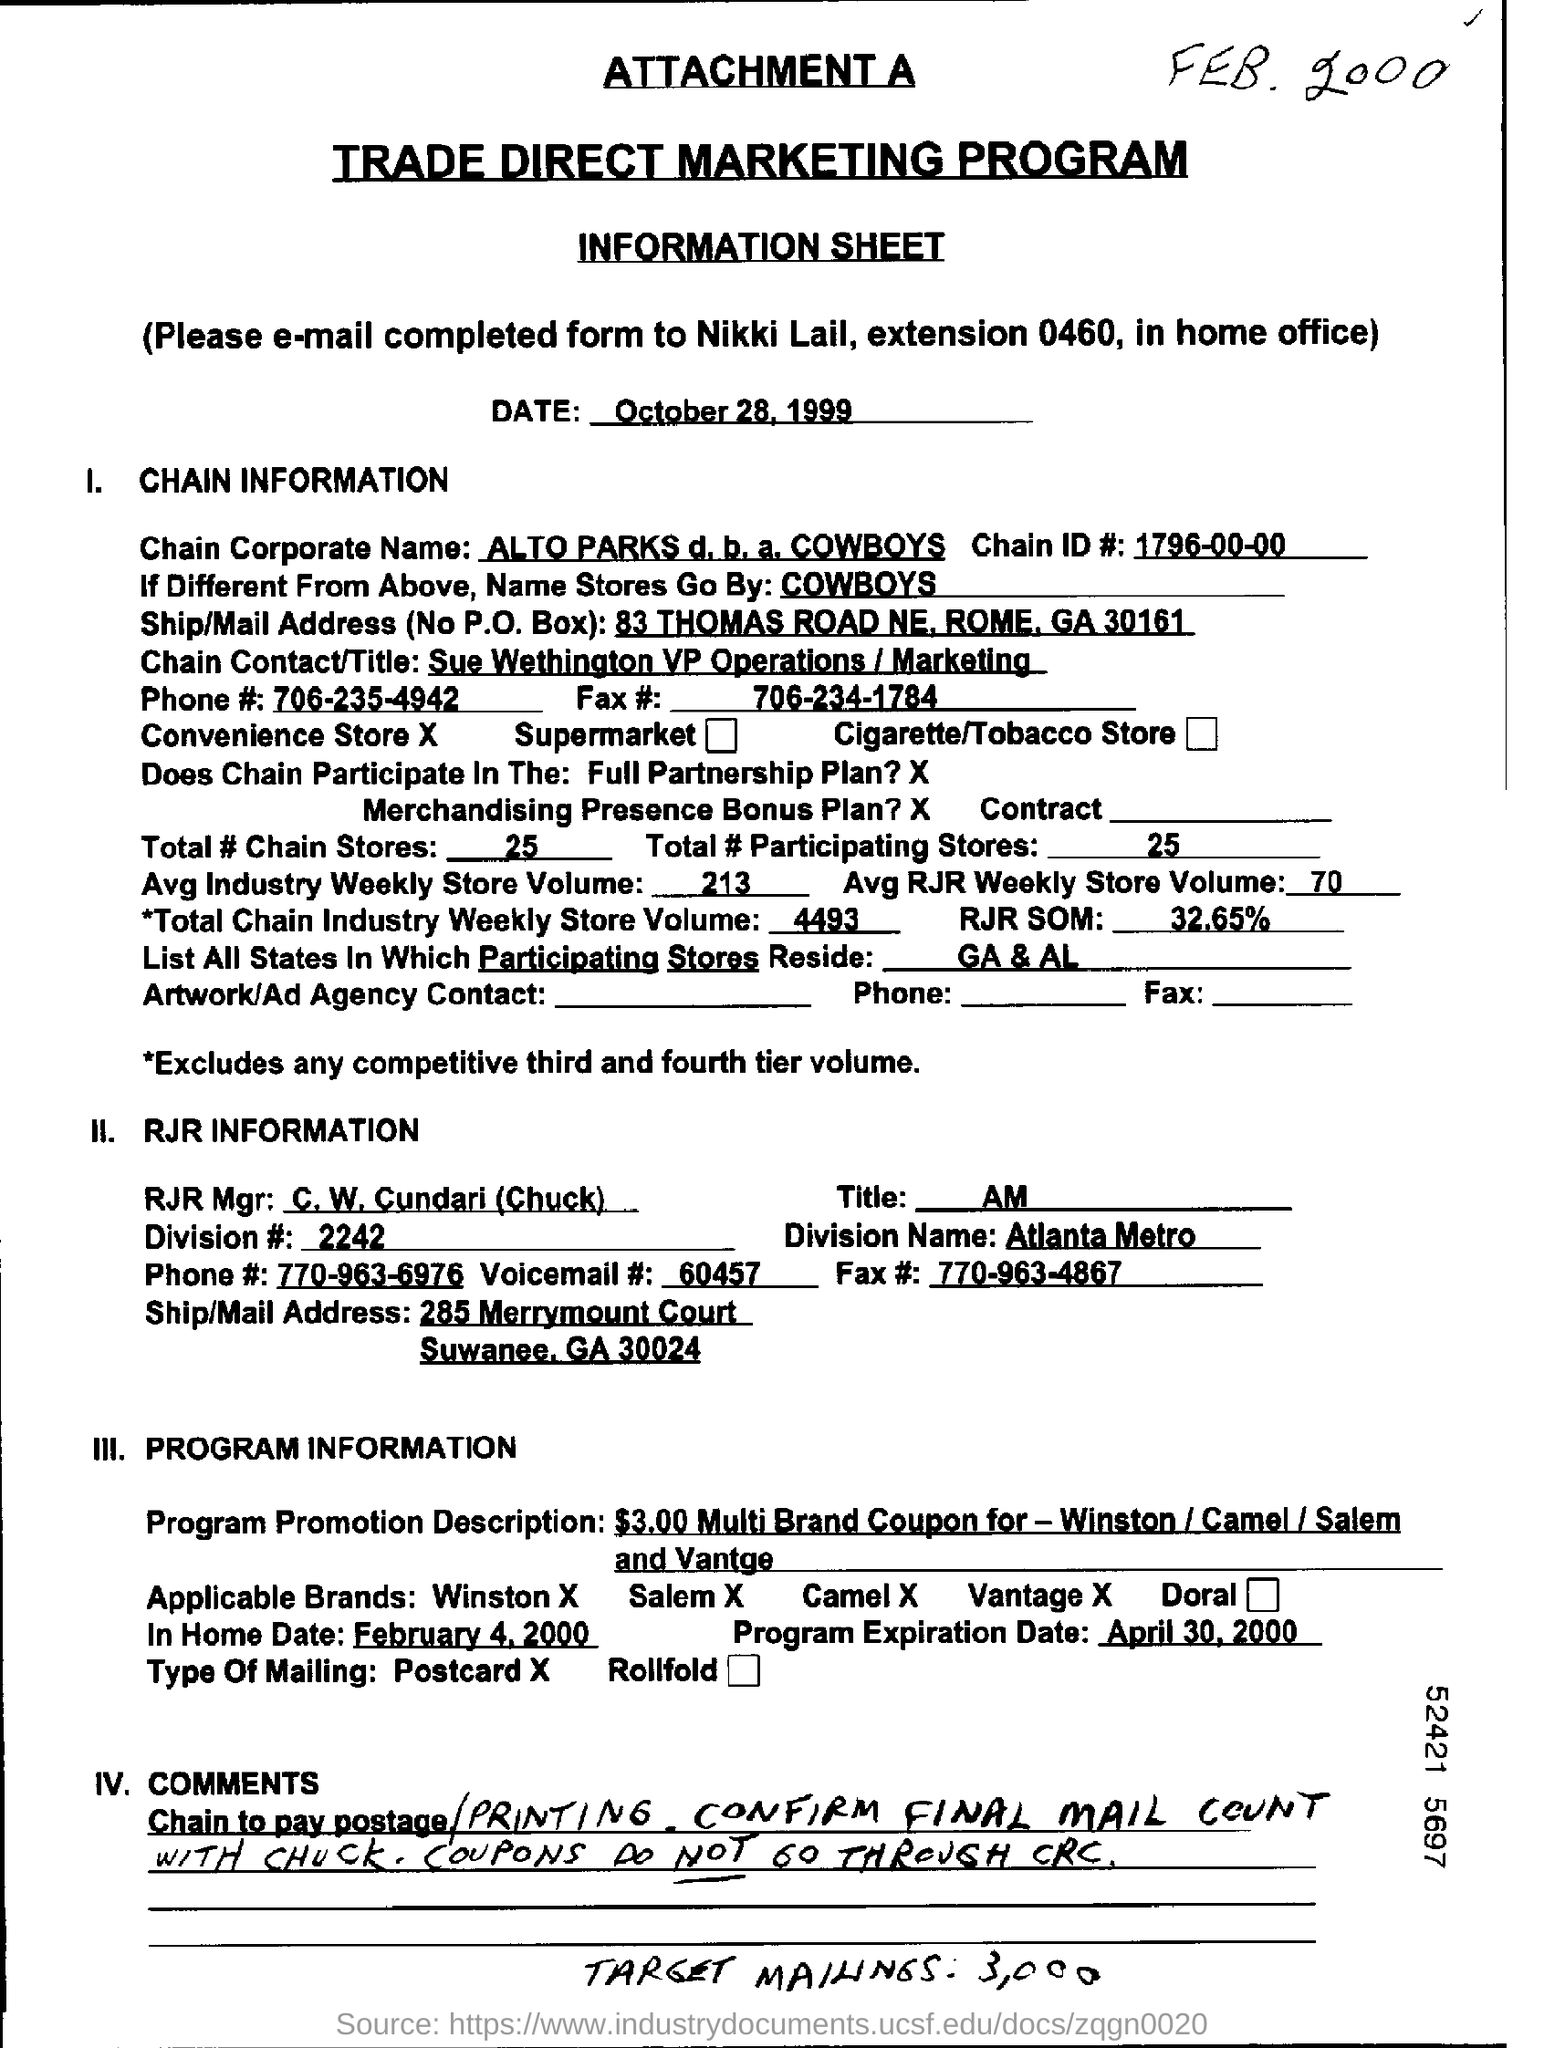What is the date on the document?
Give a very brief answer. October 28, 1999. What is the Chain ID #?
Your answer should be compact. 1796-00-00. What is the Phone # for Chain?
Keep it short and to the point. 706-235-4942. What is the Fax # for Chain?
Make the answer very short. 706-234-1784. What is the Total # Chain Stores?
Your answer should be compact. 25. What is the Total # Participating Stores?
Provide a succinct answer. 25. What is the In Home Date?
Keep it short and to the point. February 4 , 2000. What is the Voicemail #?
Your answer should be compact. 60457. 